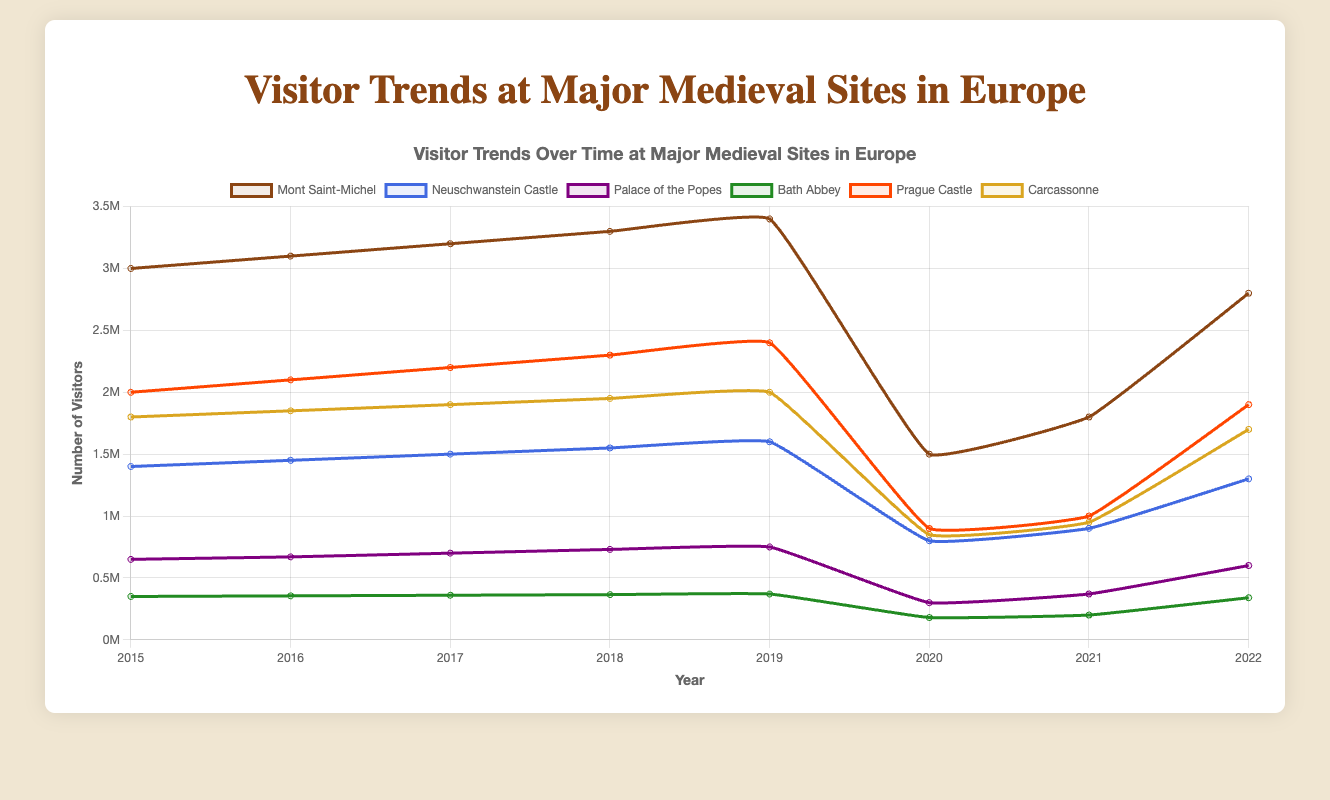What was the difference in the number of visitors to Mont Saint-Michel between 2019 and 2020? To find the difference, subtract the 2020 visitor count from the 2019 count: 3,400,000 - 1,500,000 = 1,900,000
Answer: 1,900,000 Which site had the highest number of visitors in 2018? Looking at the 2018 data, Mont Saint-Michel had the highest number of visitors at 3,300,000
Answer: Mont Saint-Michel What was the total number of visitors to Carcassonne in the years 2015 and 2016 combined? Sum the visitors of Carcassonne from 2015 and 2016: 1,800,000 + 1,850,000 = 3,650,000
Answer: 3,650,000 How did the number of visitors to the Palace of the Popes change from 2017 to 2018? Subtract the number of visitors in 2017 from the number in 2018: 730,000 - 700,000 = 30,000
Answer: Increased by 30,000 Which site experienced the largest decline in visitors from 2019 to 2020? Subtract the number of visitors in 2020 from 2019 for all sites and compare the differences. Mont Saint-Michel had the largest decline from 3,400,000 to 1,500,000, a decrease of 1,900,000
Answer: Mont Saint-Michel What is the average number of visitors to Neuschwanstein Castle over the years 2015 to 2017? Sum the visitors for the years 2015-2017 and divide by 3: (1,400,000 + 1,450,000 + 1,500,000) / 3 = 4,350,000 / 3 = 1,450,000
Answer: 1,450,000 Did Bath Abbey have more or fewer visitors in 2016 compared to 2022? Compare Bath Abbey's visitor numbers in 2016 (355,000) and 2022 (340,000). Since 355,000 is greater than 340,000, Bath Abbey had more visitors in 2016
Answer: More What was the trend in visitor numbers to Prague Castle from 2015 to 2019? Observing the data for Prague Castle from 2015 to 2019 shows an increasing trend: 2,000,000 → 2,100,000 → 2,200,000 → 2,300,000 → 2,400,000
Answer: Increasing trend Which site had the lowest number of visitors in 2021? Looking at the 2021 data, Bath Abbey had the lowest number of visitors at 200,000
Answer: Bath Abbey 